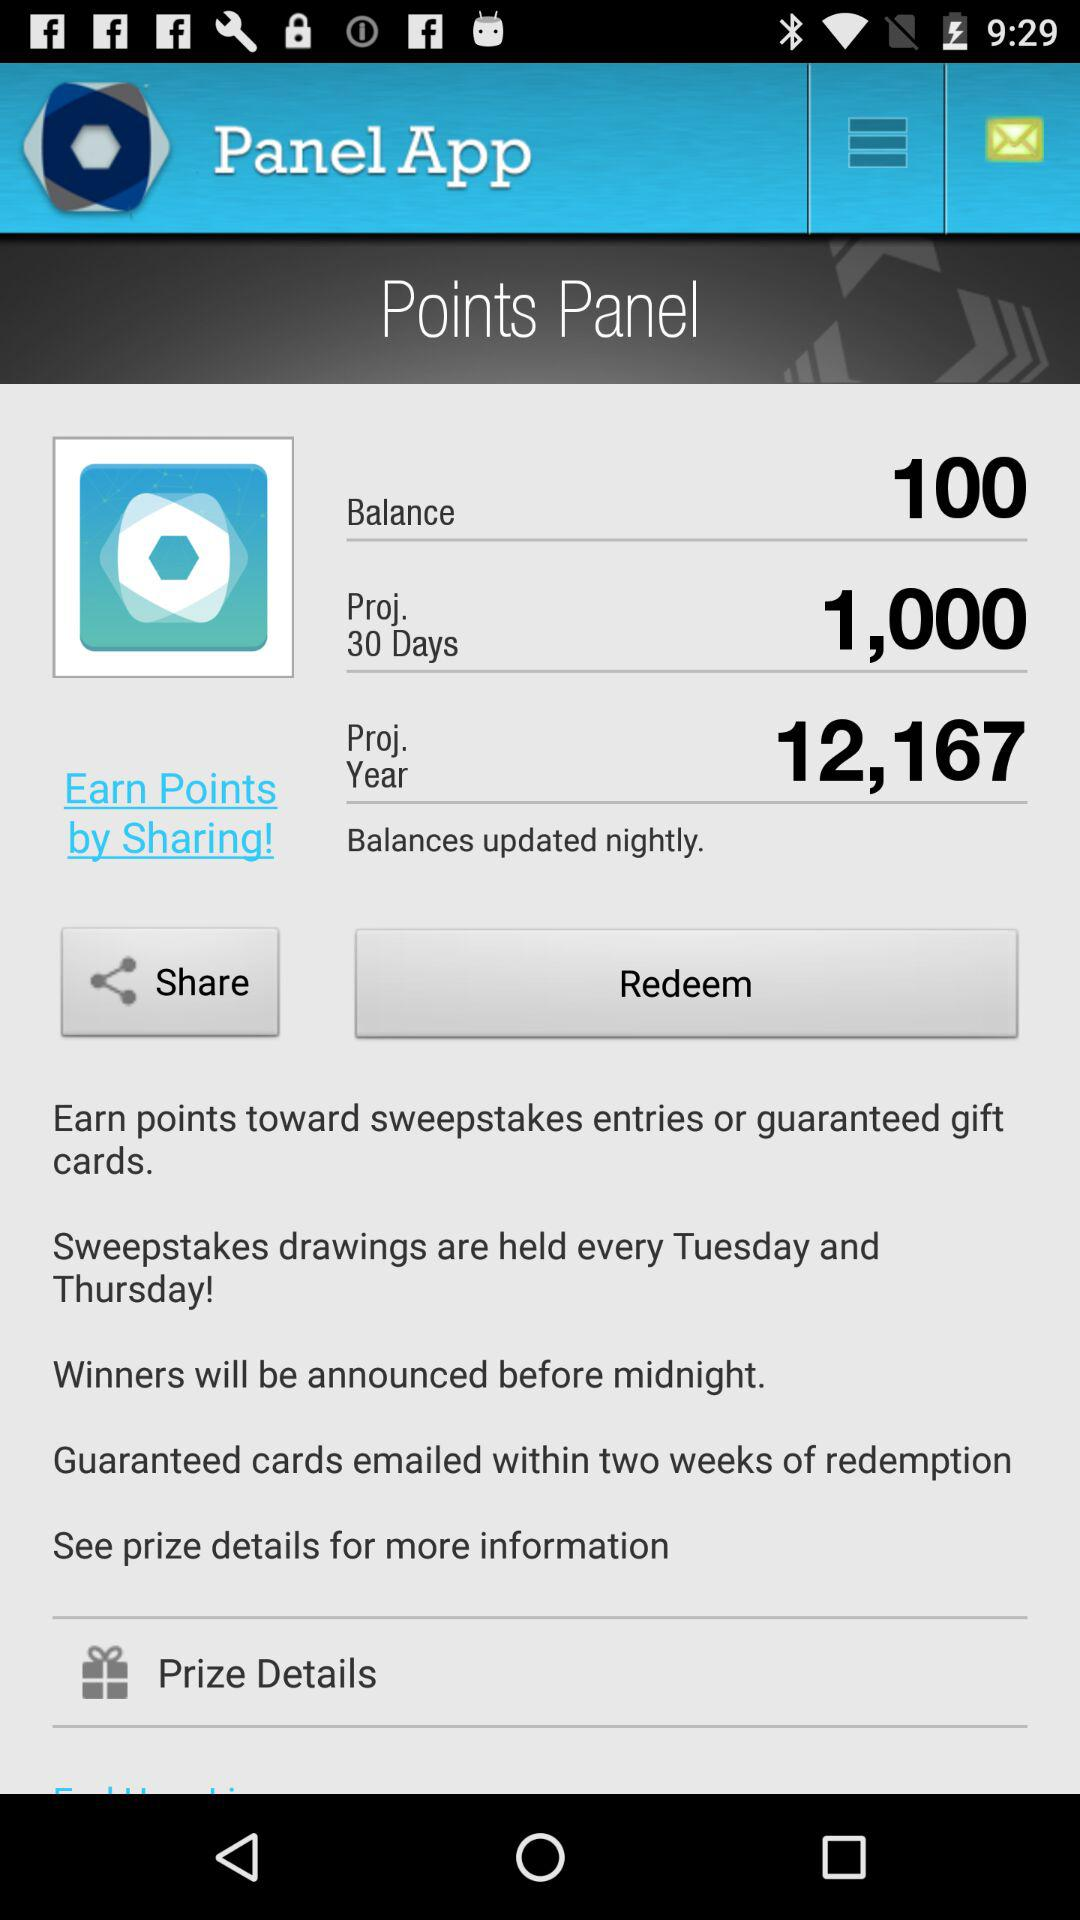When will the winners be announced? The winners will be announced before midnight. 